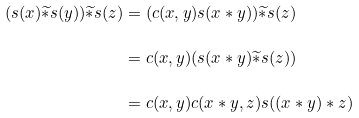Convert formula to latex. <formula><loc_0><loc_0><loc_500><loc_500>( s ( x ) \widetilde { * } s ( y ) ) \widetilde { * } s ( z ) & = ( c ( x , y ) s ( x * y ) ) \widetilde { * } s ( z ) \\ & = c ( x , y ) ( s ( x * y ) \widetilde { * } s ( z ) ) \\ & = c ( x , y ) c ( x * y , z ) s ( ( x * y ) * z )</formula> 